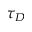Convert formula to latex. <formula><loc_0><loc_0><loc_500><loc_500>\tau _ { D }</formula> 